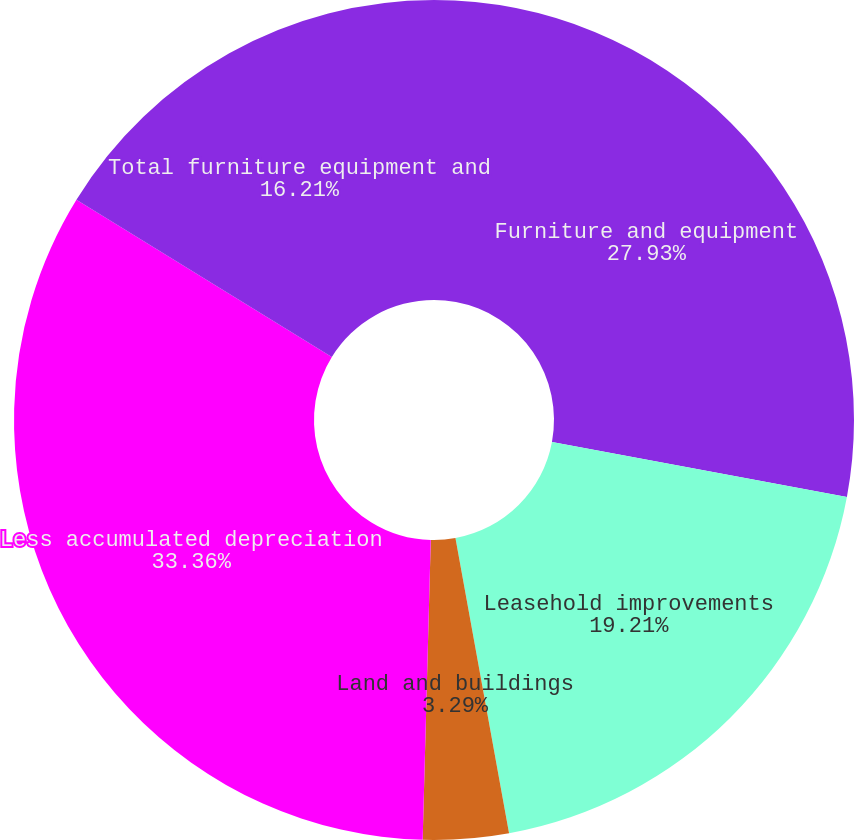Convert chart to OTSL. <chart><loc_0><loc_0><loc_500><loc_500><pie_chart><fcel>Furniture and equipment<fcel>Leasehold improvements<fcel>Land and buildings<fcel>Less accumulated depreciation<fcel>Total furniture equipment and<nl><fcel>27.93%<fcel>19.21%<fcel>3.29%<fcel>33.36%<fcel>16.21%<nl></chart> 